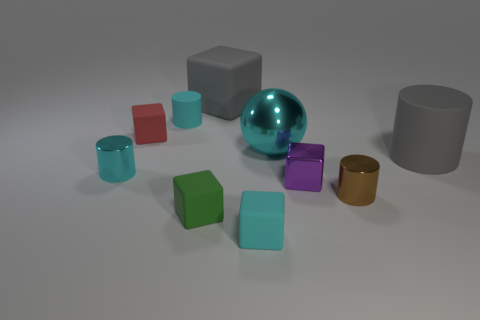How many objects are large gray metallic spheres or rubber things?
Your response must be concise. 6. What color is the large object that is in front of the big metallic sphere?
Your answer should be very brief. Gray. Are there fewer cubes right of the big rubber cylinder than matte blocks?
Offer a very short reply. Yes. What size is the shiny cylinder that is the same color as the ball?
Provide a succinct answer. Small. Is there anything else that has the same size as the brown metallic object?
Make the answer very short. Yes. Do the small purple block and the green object have the same material?
Give a very brief answer. No. How many objects are tiny objects in front of the red matte block or big gray things that are to the right of the small shiny cube?
Offer a very short reply. 6. Is there a rubber object of the same size as the red block?
Provide a succinct answer. Yes. What color is the tiny matte thing that is the same shape as the tiny brown metal thing?
Your answer should be compact. Cyan. Are there any tiny purple metal blocks to the left of the matte thing in front of the green rubber block?
Your answer should be very brief. No. 